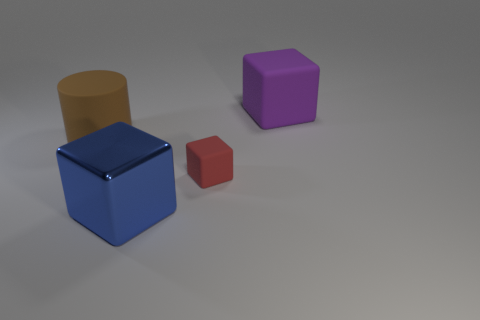Is there a rubber block of the same color as the tiny object?
Provide a short and direct response. No. Does the small object have the same color as the big matte object to the right of the large blue block?
Offer a terse response. No. There is a large cube on the right side of the big thing in front of the big brown rubber object; what color is it?
Your answer should be very brief. Purple. Are there any large matte cubes in front of the rubber block to the left of the large object that is behind the large brown cylinder?
Offer a terse response. No. What is the color of the other block that is the same material as the purple cube?
Provide a short and direct response. Red. How many large things are the same material as the blue block?
Keep it short and to the point. 0. Is the red thing made of the same material as the thing that is to the left of the blue metal cube?
Provide a succinct answer. Yes. How many objects are large matte objects that are to the right of the small rubber block or green metallic cylinders?
Keep it short and to the point. 1. What is the size of the matte cube that is in front of the purple matte thing that is to the right of the object left of the large blue metallic thing?
Provide a short and direct response. Small. Is there anything else that has the same shape as the brown rubber thing?
Provide a succinct answer. No. 